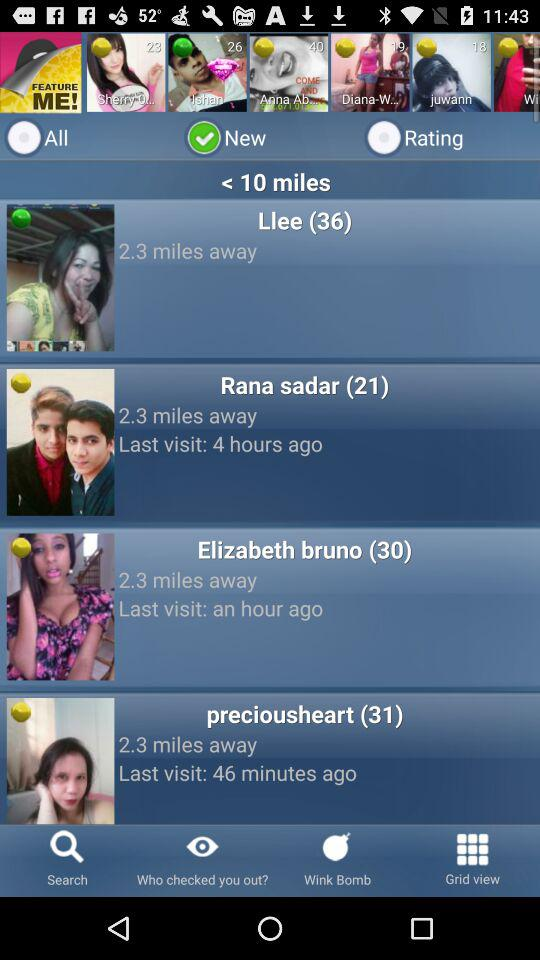How many miles away is the person with the highest last visit time?
Answer the question using a single word or phrase. 2.3 